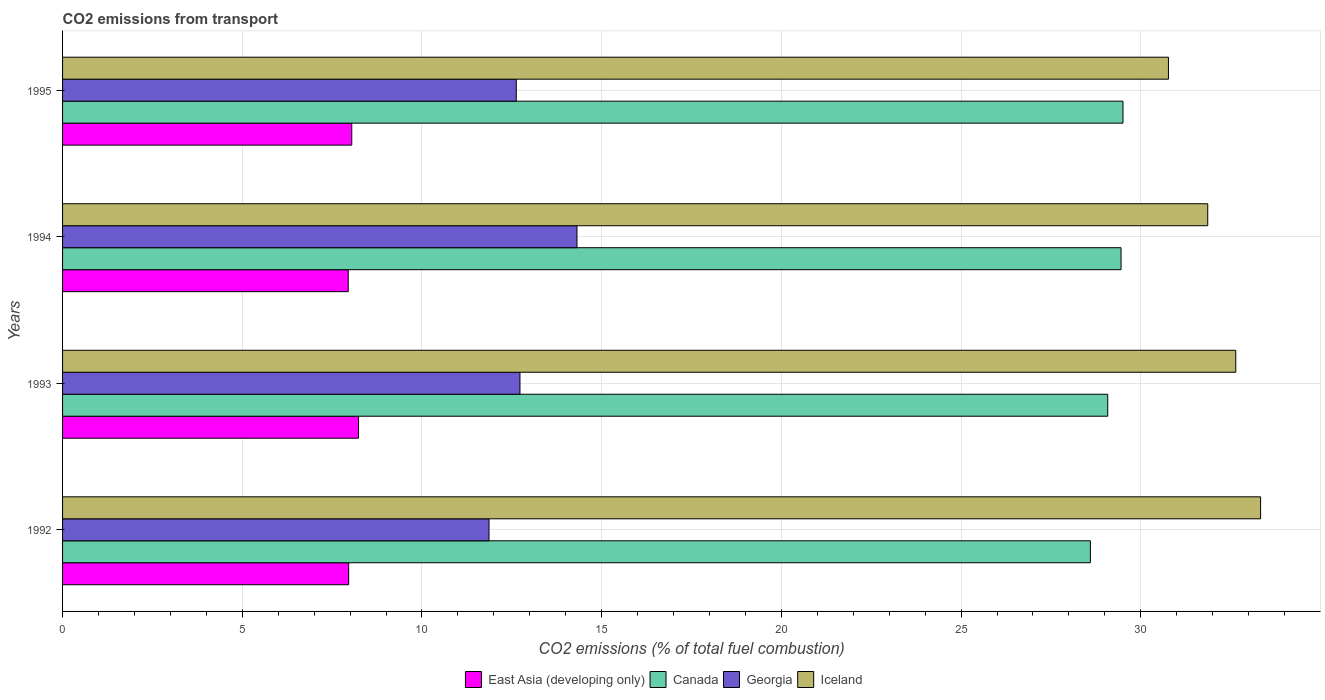In how many cases, is the number of bars for a given year not equal to the number of legend labels?
Your answer should be very brief. 0. What is the total CO2 emitted in East Asia (developing only) in 1995?
Provide a short and direct response. 8.05. Across all years, what is the maximum total CO2 emitted in Georgia?
Provide a succinct answer. 14.31. Across all years, what is the minimum total CO2 emitted in East Asia (developing only)?
Offer a terse response. 7.95. What is the total total CO2 emitted in East Asia (developing only) in the graph?
Make the answer very short. 32.19. What is the difference between the total CO2 emitted in Georgia in 1992 and that in 1995?
Make the answer very short. -0.76. What is the difference between the total CO2 emitted in East Asia (developing only) in 1992 and the total CO2 emitted in Iceland in 1995?
Your answer should be compact. -22.81. What is the average total CO2 emitted in Georgia per year?
Offer a terse response. 12.88. In the year 1994, what is the difference between the total CO2 emitted in Iceland and total CO2 emitted in East Asia (developing only)?
Make the answer very short. 23.91. In how many years, is the total CO2 emitted in East Asia (developing only) greater than 3 ?
Your response must be concise. 4. What is the ratio of the total CO2 emitted in Georgia in 1992 to that in 1993?
Provide a short and direct response. 0.93. Is the difference between the total CO2 emitted in Iceland in 1992 and 1994 greater than the difference between the total CO2 emitted in East Asia (developing only) in 1992 and 1994?
Offer a terse response. Yes. What is the difference between the highest and the second highest total CO2 emitted in East Asia (developing only)?
Give a very brief answer. 0.19. What is the difference between the highest and the lowest total CO2 emitted in Iceland?
Provide a short and direct response. 2.56. Is the sum of the total CO2 emitted in Iceland in 1993 and 1994 greater than the maximum total CO2 emitted in East Asia (developing only) across all years?
Offer a terse response. Yes. Is it the case that in every year, the sum of the total CO2 emitted in East Asia (developing only) and total CO2 emitted in Georgia is greater than the sum of total CO2 emitted in Canada and total CO2 emitted in Iceland?
Ensure brevity in your answer.  Yes. What does the 3rd bar from the bottom in 1995 represents?
Ensure brevity in your answer.  Georgia. How many bars are there?
Provide a short and direct response. 16. Are all the bars in the graph horizontal?
Keep it short and to the point. Yes. What is the difference between two consecutive major ticks on the X-axis?
Give a very brief answer. 5. Are the values on the major ticks of X-axis written in scientific E-notation?
Offer a very short reply. No. Where does the legend appear in the graph?
Make the answer very short. Bottom center. What is the title of the graph?
Ensure brevity in your answer.  CO2 emissions from transport. Does "Tanzania" appear as one of the legend labels in the graph?
Keep it short and to the point. No. What is the label or title of the X-axis?
Keep it short and to the point. CO2 emissions (% of total fuel combustion). What is the label or title of the Y-axis?
Make the answer very short. Years. What is the CO2 emissions (% of total fuel combustion) in East Asia (developing only) in 1992?
Ensure brevity in your answer.  7.96. What is the CO2 emissions (% of total fuel combustion) in Canada in 1992?
Your answer should be very brief. 28.6. What is the CO2 emissions (% of total fuel combustion) of Georgia in 1992?
Provide a short and direct response. 11.87. What is the CO2 emissions (% of total fuel combustion) of Iceland in 1992?
Make the answer very short. 33.33. What is the CO2 emissions (% of total fuel combustion) in East Asia (developing only) in 1993?
Ensure brevity in your answer.  8.24. What is the CO2 emissions (% of total fuel combustion) in Canada in 1993?
Your response must be concise. 29.08. What is the CO2 emissions (% of total fuel combustion) in Georgia in 1993?
Make the answer very short. 12.73. What is the CO2 emissions (% of total fuel combustion) in Iceland in 1993?
Keep it short and to the point. 32.64. What is the CO2 emissions (% of total fuel combustion) of East Asia (developing only) in 1994?
Your response must be concise. 7.95. What is the CO2 emissions (% of total fuel combustion) of Canada in 1994?
Make the answer very short. 29.45. What is the CO2 emissions (% of total fuel combustion) of Georgia in 1994?
Provide a succinct answer. 14.31. What is the CO2 emissions (% of total fuel combustion) in Iceland in 1994?
Give a very brief answer. 31.86. What is the CO2 emissions (% of total fuel combustion) of East Asia (developing only) in 1995?
Your answer should be compact. 8.05. What is the CO2 emissions (% of total fuel combustion) of Canada in 1995?
Give a very brief answer. 29.5. What is the CO2 emissions (% of total fuel combustion) of Georgia in 1995?
Keep it short and to the point. 12.62. What is the CO2 emissions (% of total fuel combustion) in Iceland in 1995?
Your answer should be compact. 30.77. Across all years, what is the maximum CO2 emissions (% of total fuel combustion) in East Asia (developing only)?
Make the answer very short. 8.24. Across all years, what is the maximum CO2 emissions (% of total fuel combustion) in Canada?
Make the answer very short. 29.5. Across all years, what is the maximum CO2 emissions (% of total fuel combustion) in Georgia?
Offer a terse response. 14.31. Across all years, what is the maximum CO2 emissions (% of total fuel combustion) in Iceland?
Your answer should be compact. 33.33. Across all years, what is the minimum CO2 emissions (% of total fuel combustion) in East Asia (developing only)?
Make the answer very short. 7.95. Across all years, what is the minimum CO2 emissions (% of total fuel combustion) of Canada?
Make the answer very short. 28.6. Across all years, what is the minimum CO2 emissions (% of total fuel combustion) of Georgia?
Your answer should be compact. 11.87. Across all years, what is the minimum CO2 emissions (% of total fuel combustion) of Iceland?
Offer a terse response. 30.77. What is the total CO2 emissions (% of total fuel combustion) in East Asia (developing only) in the graph?
Your answer should be compact. 32.19. What is the total CO2 emissions (% of total fuel combustion) in Canada in the graph?
Your response must be concise. 116.63. What is the total CO2 emissions (% of total fuel combustion) of Georgia in the graph?
Your response must be concise. 51.53. What is the total CO2 emissions (% of total fuel combustion) of Iceland in the graph?
Provide a short and direct response. 128.61. What is the difference between the CO2 emissions (% of total fuel combustion) in East Asia (developing only) in 1992 and that in 1993?
Your answer should be very brief. -0.27. What is the difference between the CO2 emissions (% of total fuel combustion) in Canada in 1992 and that in 1993?
Your response must be concise. -0.48. What is the difference between the CO2 emissions (% of total fuel combustion) of Georgia in 1992 and that in 1993?
Your answer should be very brief. -0.86. What is the difference between the CO2 emissions (% of total fuel combustion) of Iceland in 1992 and that in 1993?
Your answer should be very brief. 0.69. What is the difference between the CO2 emissions (% of total fuel combustion) in East Asia (developing only) in 1992 and that in 1994?
Provide a short and direct response. 0.01. What is the difference between the CO2 emissions (% of total fuel combustion) of Canada in 1992 and that in 1994?
Your answer should be very brief. -0.85. What is the difference between the CO2 emissions (% of total fuel combustion) of Georgia in 1992 and that in 1994?
Provide a succinct answer. -2.45. What is the difference between the CO2 emissions (% of total fuel combustion) of Iceland in 1992 and that in 1994?
Offer a very short reply. 1.47. What is the difference between the CO2 emissions (% of total fuel combustion) of East Asia (developing only) in 1992 and that in 1995?
Your answer should be very brief. -0.09. What is the difference between the CO2 emissions (% of total fuel combustion) of Canada in 1992 and that in 1995?
Offer a very short reply. -0.91. What is the difference between the CO2 emissions (% of total fuel combustion) in Georgia in 1992 and that in 1995?
Keep it short and to the point. -0.76. What is the difference between the CO2 emissions (% of total fuel combustion) of Iceland in 1992 and that in 1995?
Provide a short and direct response. 2.56. What is the difference between the CO2 emissions (% of total fuel combustion) of East Asia (developing only) in 1993 and that in 1994?
Offer a terse response. 0.29. What is the difference between the CO2 emissions (% of total fuel combustion) of Canada in 1993 and that in 1994?
Offer a very short reply. -0.37. What is the difference between the CO2 emissions (% of total fuel combustion) of Georgia in 1993 and that in 1994?
Keep it short and to the point. -1.59. What is the difference between the CO2 emissions (% of total fuel combustion) in Iceland in 1993 and that in 1994?
Ensure brevity in your answer.  0.78. What is the difference between the CO2 emissions (% of total fuel combustion) of East Asia (developing only) in 1993 and that in 1995?
Provide a short and direct response. 0.19. What is the difference between the CO2 emissions (% of total fuel combustion) in Canada in 1993 and that in 1995?
Provide a short and direct response. -0.42. What is the difference between the CO2 emissions (% of total fuel combustion) of Georgia in 1993 and that in 1995?
Offer a terse response. 0.1. What is the difference between the CO2 emissions (% of total fuel combustion) of Iceland in 1993 and that in 1995?
Make the answer very short. 1.87. What is the difference between the CO2 emissions (% of total fuel combustion) in East Asia (developing only) in 1994 and that in 1995?
Provide a succinct answer. -0.1. What is the difference between the CO2 emissions (% of total fuel combustion) of Canada in 1994 and that in 1995?
Ensure brevity in your answer.  -0.05. What is the difference between the CO2 emissions (% of total fuel combustion) in Georgia in 1994 and that in 1995?
Offer a very short reply. 1.69. What is the difference between the CO2 emissions (% of total fuel combustion) of Iceland in 1994 and that in 1995?
Your answer should be compact. 1.09. What is the difference between the CO2 emissions (% of total fuel combustion) of East Asia (developing only) in 1992 and the CO2 emissions (% of total fuel combustion) of Canada in 1993?
Offer a terse response. -21.12. What is the difference between the CO2 emissions (% of total fuel combustion) in East Asia (developing only) in 1992 and the CO2 emissions (% of total fuel combustion) in Georgia in 1993?
Keep it short and to the point. -4.77. What is the difference between the CO2 emissions (% of total fuel combustion) of East Asia (developing only) in 1992 and the CO2 emissions (% of total fuel combustion) of Iceland in 1993?
Provide a short and direct response. -24.68. What is the difference between the CO2 emissions (% of total fuel combustion) in Canada in 1992 and the CO2 emissions (% of total fuel combustion) in Georgia in 1993?
Provide a succinct answer. 15.87. What is the difference between the CO2 emissions (% of total fuel combustion) of Canada in 1992 and the CO2 emissions (% of total fuel combustion) of Iceland in 1993?
Provide a succinct answer. -4.04. What is the difference between the CO2 emissions (% of total fuel combustion) in Georgia in 1992 and the CO2 emissions (% of total fuel combustion) in Iceland in 1993?
Offer a very short reply. -20.78. What is the difference between the CO2 emissions (% of total fuel combustion) in East Asia (developing only) in 1992 and the CO2 emissions (% of total fuel combustion) in Canada in 1994?
Give a very brief answer. -21.49. What is the difference between the CO2 emissions (% of total fuel combustion) of East Asia (developing only) in 1992 and the CO2 emissions (% of total fuel combustion) of Georgia in 1994?
Make the answer very short. -6.35. What is the difference between the CO2 emissions (% of total fuel combustion) of East Asia (developing only) in 1992 and the CO2 emissions (% of total fuel combustion) of Iceland in 1994?
Ensure brevity in your answer.  -23.9. What is the difference between the CO2 emissions (% of total fuel combustion) of Canada in 1992 and the CO2 emissions (% of total fuel combustion) of Georgia in 1994?
Make the answer very short. 14.28. What is the difference between the CO2 emissions (% of total fuel combustion) in Canada in 1992 and the CO2 emissions (% of total fuel combustion) in Iceland in 1994?
Your response must be concise. -3.27. What is the difference between the CO2 emissions (% of total fuel combustion) in Georgia in 1992 and the CO2 emissions (% of total fuel combustion) in Iceland in 1994?
Provide a short and direct response. -20. What is the difference between the CO2 emissions (% of total fuel combustion) of East Asia (developing only) in 1992 and the CO2 emissions (% of total fuel combustion) of Canada in 1995?
Make the answer very short. -21.54. What is the difference between the CO2 emissions (% of total fuel combustion) in East Asia (developing only) in 1992 and the CO2 emissions (% of total fuel combustion) in Georgia in 1995?
Provide a short and direct response. -4.66. What is the difference between the CO2 emissions (% of total fuel combustion) of East Asia (developing only) in 1992 and the CO2 emissions (% of total fuel combustion) of Iceland in 1995?
Offer a terse response. -22.81. What is the difference between the CO2 emissions (% of total fuel combustion) in Canada in 1992 and the CO2 emissions (% of total fuel combustion) in Georgia in 1995?
Provide a short and direct response. 15.97. What is the difference between the CO2 emissions (% of total fuel combustion) in Canada in 1992 and the CO2 emissions (% of total fuel combustion) in Iceland in 1995?
Ensure brevity in your answer.  -2.17. What is the difference between the CO2 emissions (% of total fuel combustion) in Georgia in 1992 and the CO2 emissions (% of total fuel combustion) in Iceland in 1995?
Give a very brief answer. -18.9. What is the difference between the CO2 emissions (% of total fuel combustion) in East Asia (developing only) in 1993 and the CO2 emissions (% of total fuel combustion) in Canada in 1994?
Keep it short and to the point. -21.22. What is the difference between the CO2 emissions (% of total fuel combustion) in East Asia (developing only) in 1993 and the CO2 emissions (% of total fuel combustion) in Georgia in 1994?
Offer a very short reply. -6.08. What is the difference between the CO2 emissions (% of total fuel combustion) of East Asia (developing only) in 1993 and the CO2 emissions (% of total fuel combustion) of Iceland in 1994?
Make the answer very short. -23.63. What is the difference between the CO2 emissions (% of total fuel combustion) in Canada in 1993 and the CO2 emissions (% of total fuel combustion) in Georgia in 1994?
Give a very brief answer. 14.77. What is the difference between the CO2 emissions (% of total fuel combustion) in Canada in 1993 and the CO2 emissions (% of total fuel combustion) in Iceland in 1994?
Your response must be concise. -2.78. What is the difference between the CO2 emissions (% of total fuel combustion) in Georgia in 1993 and the CO2 emissions (% of total fuel combustion) in Iceland in 1994?
Keep it short and to the point. -19.14. What is the difference between the CO2 emissions (% of total fuel combustion) of East Asia (developing only) in 1993 and the CO2 emissions (% of total fuel combustion) of Canada in 1995?
Provide a short and direct response. -21.27. What is the difference between the CO2 emissions (% of total fuel combustion) of East Asia (developing only) in 1993 and the CO2 emissions (% of total fuel combustion) of Georgia in 1995?
Your answer should be compact. -4.39. What is the difference between the CO2 emissions (% of total fuel combustion) in East Asia (developing only) in 1993 and the CO2 emissions (% of total fuel combustion) in Iceland in 1995?
Offer a terse response. -22.53. What is the difference between the CO2 emissions (% of total fuel combustion) of Canada in 1993 and the CO2 emissions (% of total fuel combustion) of Georgia in 1995?
Make the answer very short. 16.46. What is the difference between the CO2 emissions (% of total fuel combustion) in Canada in 1993 and the CO2 emissions (% of total fuel combustion) in Iceland in 1995?
Offer a terse response. -1.69. What is the difference between the CO2 emissions (% of total fuel combustion) of Georgia in 1993 and the CO2 emissions (% of total fuel combustion) of Iceland in 1995?
Give a very brief answer. -18.04. What is the difference between the CO2 emissions (% of total fuel combustion) of East Asia (developing only) in 1994 and the CO2 emissions (% of total fuel combustion) of Canada in 1995?
Provide a short and direct response. -21.56. What is the difference between the CO2 emissions (% of total fuel combustion) in East Asia (developing only) in 1994 and the CO2 emissions (% of total fuel combustion) in Georgia in 1995?
Keep it short and to the point. -4.68. What is the difference between the CO2 emissions (% of total fuel combustion) of East Asia (developing only) in 1994 and the CO2 emissions (% of total fuel combustion) of Iceland in 1995?
Ensure brevity in your answer.  -22.82. What is the difference between the CO2 emissions (% of total fuel combustion) in Canada in 1994 and the CO2 emissions (% of total fuel combustion) in Georgia in 1995?
Your answer should be very brief. 16.83. What is the difference between the CO2 emissions (% of total fuel combustion) of Canada in 1994 and the CO2 emissions (% of total fuel combustion) of Iceland in 1995?
Keep it short and to the point. -1.32. What is the difference between the CO2 emissions (% of total fuel combustion) in Georgia in 1994 and the CO2 emissions (% of total fuel combustion) in Iceland in 1995?
Your answer should be very brief. -16.46. What is the average CO2 emissions (% of total fuel combustion) of East Asia (developing only) per year?
Your response must be concise. 8.05. What is the average CO2 emissions (% of total fuel combustion) of Canada per year?
Your answer should be compact. 29.16. What is the average CO2 emissions (% of total fuel combustion) in Georgia per year?
Provide a short and direct response. 12.88. What is the average CO2 emissions (% of total fuel combustion) in Iceland per year?
Give a very brief answer. 32.15. In the year 1992, what is the difference between the CO2 emissions (% of total fuel combustion) of East Asia (developing only) and CO2 emissions (% of total fuel combustion) of Canada?
Keep it short and to the point. -20.64. In the year 1992, what is the difference between the CO2 emissions (% of total fuel combustion) in East Asia (developing only) and CO2 emissions (% of total fuel combustion) in Georgia?
Your answer should be compact. -3.9. In the year 1992, what is the difference between the CO2 emissions (% of total fuel combustion) in East Asia (developing only) and CO2 emissions (% of total fuel combustion) in Iceland?
Give a very brief answer. -25.37. In the year 1992, what is the difference between the CO2 emissions (% of total fuel combustion) in Canada and CO2 emissions (% of total fuel combustion) in Georgia?
Offer a very short reply. 16.73. In the year 1992, what is the difference between the CO2 emissions (% of total fuel combustion) of Canada and CO2 emissions (% of total fuel combustion) of Iceland?
Provide a short and direct response. -4.74. In the year 1992, what is the difference between the CO2 emissions (% of total fuel combustion) of Georgia and CO2 emissions (% of total fuel combustion) of Iceland?
Offer a very short reply. -21.47. In the year 1993, what is the difference between the CO2 emissions (% of total fuel combustion) of East Asia (developing only) and CO2 emissions (% of total fuel combustion) of Canada?
Your answer should be very brief. -20.85. In the year 1993, what is the difference between the CO2 emissions (% of total fuel combustion) of East Asia (developing only) and CO2 emissions (% of total fuel combustion) of Georgia?
Keep it short and to the point. -4.49. In the year 1993, what is the difference between the CO2 emissions (% of total fuel combustion) in East Asia (developing only) and CO2 emissions (% of total fuel combustion) in Iceland?
Provide a succinct answer. -24.41. In the year 1993, what is the difference between the CO2 emissions (% of total fuel combustion) in Canada and CO2 emissions (% of total fuel combustion) in Georgia?
Provide a short and direct response. 16.35. In the year 1993, what is the difference between the CO2 emissions (% of total fuel combustion) in Canada and CO2 emissions (% of total fuel combustion) in Iceland?
Your response must be concise. -3.56. In the year 1993, what is the difference between the CO2 emissions (% of total fuel combustion) in Georgia and CO2 emissions (% of total fuel combustion) in Iceland?
Your answer should be very brief. -19.92. In the year 1994, what is the difference between the CO2 emissions (% of total fuel combustion) of East Asia (developing only) and CO2 emissions (% of total fuel combustion) of Canada?
Make the answer very short. -21.5. In the year 1994, what is the difference between the CO2 emissions (% of total fuel combustion) in East Asia (developing only) and CO2 emissions (% of total fuel combustion) in Georgia?
Offer a very short reply. -6.36. In the year 1994, what is the difference between the CO2 emissions (% of total fuel combustion) of East Asia (developing only) and CO2 emissions (% of total fuel combustion) of Iceland?
Make the answer very short. -23.91. In the year 1994, what is the difference between the CO2 emissions (% of total fuel combustion) of Canada and CO2 emissions (% of total fuel combustion) of Georgia?
Your answer should be compact. 15.14. In the year 1994, what is the difference between the CO2 emissions (% of total fuel combustion) in Canada and CO2 emissions (% of total fuel combustion) in Iceland?
Your answer should be compact. -2.41. In the year 1994, what is the difference between the CO2 emissions (% of total fuel combustion) of Georgia and CO2 emissions (% of total fuel combustion) of Iceland?
Provide a short and direct response. -17.55. In the year 1995, what is the difference between the CO2 emissions (% of total fuel combustion) in East Asia (developing only) and CO2 emissions (% of total fuel combustion) in Canada?
Offer a terse response. -21.46. In the year 1995, what is the difference between the CO2 emissions (% of total fuel combustion) in East Asia (developing only) and CO2 emissions (% of total fuel combustion) in Georgia?
Your answer should be very brief. -4.58. In the year 1995, what is the difference between the CO2 emissions (% of total fuel combustion) of East Asia (developing only) and CO2 emissions (% of total fuel combustion) of Iceland?
Your answer should be compact. -22.72. In the year 1995, what is the difference between the CO2 emissions (% of total fuel combustion) in Canada and CO2 emissions (% of total fuel combustion) in Georgia?
Offer a terse response. 16.88. In the year 1995, what is the difference between the CO2 emissions (% of total fuel combustion) of Canada and CO2 emissions (% of total fuel combustion) of Iceland?
Give a very brief answer. -1.26. In the year 1995, what is the difference between the CO2 emissions (% of total fuel combustion) of Georgia and CO2 emissions (% of total fuel combustion) of Iceland?
Your answer should be very brief. -18.15. What is the ratio of the CO2 emissions (% of total fuel combustion) in East Asia (developing only) in 1992 to that in 1993?
Make the answer very short. 0.97. What is the ratio of the CO2 emissions (% of total fuel combustion) in Canada in 1992 to that in 1993?
Keep it short and to the point. 0.98. What is the ratio of the CO2 emissions (% of total fuel combustion) of Georgia in 1992 to that in 1993?
Give a very brief answer. 0.93. What is the ratio of the CO2 emissions (% of total fuel combustion) of Iceland in 1992 to that in 1993?
Your answer should be compact. 1.02. What is the ratio of the CO2 emissions (% of total fuel combustion) of Georgia in 1992 to that in 1994?
Offer a terse response. 0.83. What is the ratio of the CO2 emissions (% of total fuel combustion) in Iceland in 1992 to that in 1994?
Give a very brief answer. 1.05. What is the ratio of the CO2 emissions (% of total fuel combustion) in East Asia (developing only) in 1992 to that in 1995?
Your response must be concise. 0.99. What is the ratio of the CO2 emissions (% of total fuel combustion) in Canada in 1992 to that in 1995?
Give a very brief answer. 0.97. What is the ratio of the CO2 emissions (% of total fuel combustion) in Georgia in 1992 to that in 1995?
Provide a succinct answer. 0.94. What is the ratio of the CO2 emissions (% of total fuel combustion) of Iceland in 1992 to that in 1995?
Ensure brevity in your answer.  1.08. What is the ratio of the CO2 emissions (% of total fuel combustion) in East Asia (developing only) in 1993 to that in 1994?
Provide a succinct answer. 1.04. What is the ratio of the CO2 emissions (% of total fuel combustion) of Canada in 1993 to that in 1994?
Make the answer very short. 0.99. What is the ratio of the CO2 emissions (% of total fuel combustion) of Georgia in 1993 to that in 1994?
Make the answer very short. 0.89. What is the ratio of the CO2 emissions (% of total fuel combustion) in Iceland in 1993 to that in 1994?
Offer a very short reply. 1.02. What is the ratio of the CO2 emissions (% of total fuel combustion) in East Asia (developing only) in 1993 to that in 1995?
Keep it short and to the point. 1.02. What is the ratio of the CO2 emissions (% of total fuel combustion) in Canada in 1993 to that in 1995?
Your answer should be compact. 0.99. What is the ratio of the CO2 emissions (% of total fuel combustion) in Georgia in 1993 to that in 1995?
Provide a short and direct response. 1.01. What is the ratio of the CO2 emissions (% of total fuel combustion) in Iceland in 1993 to that in 1995?
Your response must be concise. 1.06. What is the ratio of the CO2 emissions (% of total fuel combustion) in East Asia (developing only) in 1994 to that in 1995?
Ensure brevity in your answer.  0.99. What is the ratio of the CO2 emissions (% of total fuel combustion) in Georgia in 1994 to that in 1995?
Give a very brief answer. 1.13. What is the ratio of the CO2 emissions (% of total fuel combustion) of Iceland in 1994 to that in 1995?
Give a very brief answer. 1.04. What is the difference between the highest and the second highest CO2 emissions (% of total fuel combustion) in East Asia (developing only)?
Your answer should be compact. 0.19. What is the difference between the highest and the second highest CO2 emissions (% of total fuel combustion) of Canada?
Your answer should be very brief. 0.05. What is the difference between the highest and the second highest CO2 emissions (% of total fuel combustion) of Georgia?
Ensure brevity in your answer.  1.59. What is the difference between the highest and the second highest CO2 emissions (% of total fuel combustion) in Iceland?
Give a very brief answer. 0.69. What is the difference between the highest and the lowest CO2 emissions (% of total fuel combustion) of East Asia (developing only)?
Your answer should be very brief. 0.29. What is the difference between the highest and the lowest CO2 emissions (% of total fuel combustion) in Canada?
Your answer should be compact. 0.91. What is the difference between the highest and the lowest CO2 emissions (% of total fuel combustion) of Georgia?
Your answer should be very brief. 2.45. What is the difference between the highest and the lowest CO2 emissions (% of total fuel combustion) in Iceland?
Your answer should be very brief. 2.56. 